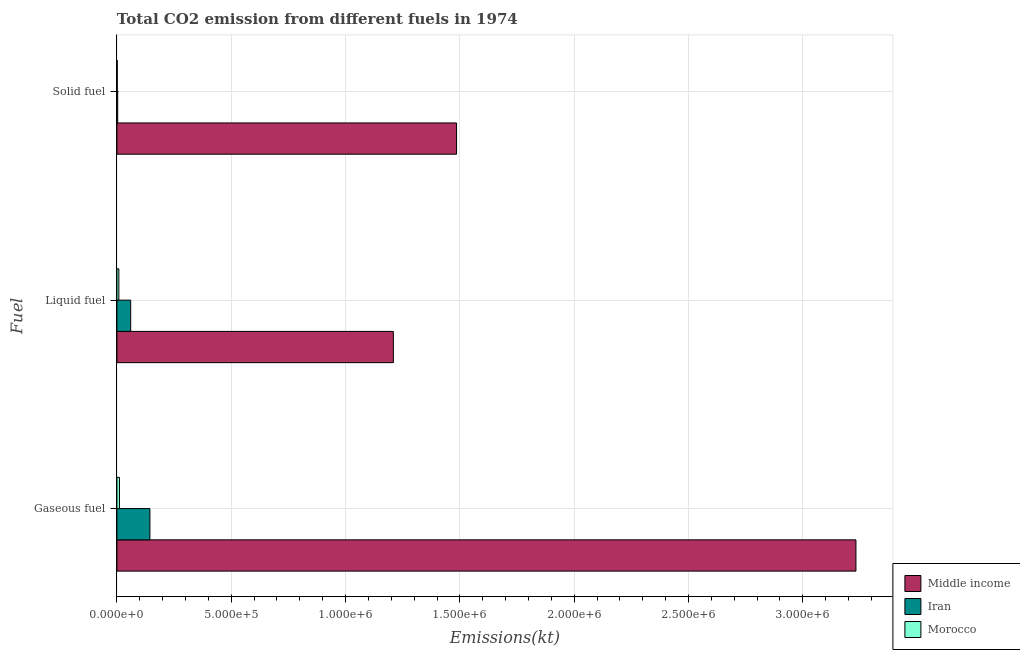How many groups of bars are there?
Offer a terse response. 3. Are the number of bars per tick equal to the number of legend labels?
Ensure brevity in your answer.  Yes. How many bars are there on the 1st tick from the bottom?
Your answer should be compact. 3. What is the label of the 3rd group of bars from the top?
Give a very brief answer. Gaseous fuel. What is the amount of co2 emissions from solid fuel in Morocco?
Provide a succinct answer. 1554.81. Across all countries, what is the maximum amount of co2 emissions from gaseous fuel?
Make the answer very short. 3.23e+06. Across all countries, what is the minimum amount of co2 emissions from gaseous fuel?
Keep it short and to the point. 1.11e+04. In which country was the amount of co2 emissions from solid fuel maximum?
Give a very brief answer. Middle income. In which country was the amount of co2 emissions from solid fuel minimum?
Provide a succinct answer. Morocco. What is the total amount of co2 emissions from liquid fuel in the graph?
Provide a succinct answer. 1.28e+06. What is the difference between the amount of co2 emissions from gaseous fuel in Morocco and that in Middle income?
Offer a very short reply. -3.22e+06. What is the difference between the amount of co2 emissions from solid fuel in Iran and the amount of co2 emissions from liquid fuel in Middle income?
Your response must be concise. -1.21e+06. What is the average amount of co2 emissions from gaseous fuel per country?
Ensure brevity in your answer.  1.13e+06. What is the difference between the amount of co2 emissions from solid fuel and amount of co2 emissions from gaseous fuel in Morocco?
Offer a terse response. -9581.87. In how many countries, is the amount of co2 emissions from gaseous fuel greater than 1600000 kt?
Offer a very short reply. 1. What is the ratio of the amount of co2 emissions from solid fuel in Iran to that in Middle income?
Provide a short and direct response. 0. What is the difference between the highest and the second highest amount of co2 emissions from solid fuel?
Ensure brevity in your answer.  1.48e+06. What is the difference between the highest and the lowest amount of co2 emissions from liquid fuel?
Your answer should be very brief. 1.20e+06. What does the 2nd bar from the bottom in Gaseous fuel represents?
Ensure brevity in your answer.  Iran. Is it the case that in every country, the sum of the amount of co2 emissions from gaseous fuel and amount of co2 emissions from liquid fuel is greater than the amount of co2 emissions from solid fuel?
Your answer should be very brief. Yes. Are all the bars in the graph horizontal?
Ensure brevity in your answer.  Yes. How many countries are there in the graph?
Give a very brief answer. 3. Are the values on the major ticks of X-axis written in scientific E-notation?
Make the answer very short. Yes. What is the title of the graph?
Your answer should be compact. Total CO2 emission from different fuels in 1974. Does "Madagascar" appear as one of the legend labels in the graph?
Ensure brevity in your answer.  No. What is the label or title of the X-axis?
Keep it short and to the point. Emissions(kt). What is the label or title of the Y-axis?
Your answer should be compact. Fuel. What is the Emissions(kt) of Middle income in Gaseous fuel?
Keep it short and to the point. 3.23e+06. What is the Emissions(kt) in Iran in Gaseous fuel?
Offer a very short reply. 1.44e+05. What is the Emissions(kt) in Morocco in Gaseous fuel?
Ensure brevity in your answer.  1.11e+04. What is the Emissions(kt) of Middle income in Liquid fuel?
Make the answer very short. 1.21e+06. What is the Emissions(kt) of Iran in Liquid fuel?
Ensure brevity in your answer.  6.02e+04. What is the Emissions(kt) in Morocco in Liquid fuel?
Your answer should be compact. 8507.44. What is the Emissions(kt) in Middle income in Solid fuel?
Keep it short and to the point. 1.49e+06. What is the Emissions(kt) of Iran in Solid fuel?
Ensure brevity in your answer.  3384.64. What is the Emissions(kt) in Morocco in Solid fuel?
Provide a short and direct response. 1554.81. Across all Fuel, what is the maximum Emissions(kt) in Middle income?
Offer a terse response. 3.23e+06. Across all Fuel, what is the maximum Emissions(kt) in Iran?
Provide a short and direct response. 1.44e+05. Across all Fuel, what is the maximum Emissions(kt) in Morocco?
Make the answer very short. 1.11e+04. Across all Fuel, what is the minimum Emissions(kt) in Middle income?
Your response must be concise. 1.21e+06. Across all Fuel, what is the minimum Emissions(kt) in Iran?
Provide a short and direct response. 3384.64. Across all Fuel, what is the minimum Emissions(kt) of Morocco?
Your answer should be very brief. 1554.81. What is the total Emissions(kt) in Middle income in the graph?
Offer a very short reply. 5.93e+06. What is the total Emissions(kt) in Iran in the graph?
Your response must be concise. 2.08e+05. What is the total Emissions(kt) in Morocco in the graph?
Make the answer very short. 2.12e+04. What is the difference between the Emissions(kt) in Middle income in Gaseous fuel and that in Liquid fuel?
Ensure brevity in your answer.  2.02e+06. What is the difference between the Emissions(kt) in Iran in Gaseous fuel and that in Liquid fuel?
Your answer should be compact. 8.41e+04. What is the difference between the Emissions(kt) in Morocco in Gaseous fuel and that in Liquid fuel?
Provide a succinct answer. 2629.24. What is the difference between the Emissions(kt) in Middle income in Gaseous fuel and that in Solid fuel?
Give a very brief answer. 1.75e+06. What is the difference between the Emissions(kt) of Iran in Gaseous fuel and that in Solid fuel?
Make the answer very short. 1.41e+05. What is the difference between the Emissions(kt) in Morocco in Gaseous fuel and that in Solid fuel?
Keep it short and to the point. 9581.87. What is the difference between the Emissions(kt) of Middle income in Liquid fuel and that in Solid fuel?
Your response must be concise. -2.76e+05. What is the difference between the Emissions(kt) of Iran in Liquid fuel and that in Solid fuel?
Keep it short and to the point. 5.68e+04. What is the difference between the Emissions(kt) of Morocco in Liquid fuel and that in Solid fuel?
Provide a short and direct response. 6952.63. What is the difference between the Emissions(kt) in Middle income in Gaseous fuel and the Emissions(kt) in Iran in Liquid fuel?
Provide a succinct answer. 3.17e+06. What is the difference between the Emissions(kt) of Middle income in Gaseous fuel and the Emissions(kt) of Morocco in Liquid fuel?
Offer a very short reply. 3.22e+06. What is the difference between the Emissions(kt) of Iran in Gaseous fuel and the Emissions(kt) of Morocco in Liquid fuel?
Offer a terse response. 1.36e+05. What is the difference between the Emissions(kt) of Middle income in Gaseous fuel and the Emissions(kt) of Iran in Solid fuel?
Your response must be concise. 3.23e+06. What is the difference between the Emissions(kt) in Middle income in Gaseous fuel and the Emissions(kt) in Morocco in Solid fuel?
Give a very brief answer. 3.23e+06. What is the difference between the Emissions(kt) of Iran in Gaseous fuel and the Emissions(kt) of Morocco in Solid fuel?
Keep it short and to the point. 1.43e+05. What is the difference between the Emissions(kt) in Middle income in Liquid fuel and the Emissions(kt) in Iran in Solid fuel?
Provide a short and direct response. 1.21e+06. What is the difference between the Emissions(kt) in Middle income in Liquid fuel and the Emissions(kt) in Morocco in Solid fuel?
Provide a succinct answer. 1.21e+06. What is the difference between the Emissions(kt) of Iran in Liquid fuel and the Emissions(kt) of Morocco in Solid fuel?
Offer a very short reply. 5.86e+04. What is the average Emissions(kt) in Middle income per Fuel?
Give a very brief answer. 1.98e+06. What is the average Emissions(kt) in Iran per Fuel?
Offer a very short reply. 6.93e+04. What is the average Emissions(kt) of Morocco per Fuel?
Keep it short and to the point. 7066.31. What is the difference between the Emissions(kt) of Middle income and Emissions(kt) of Iran in Gaseous fuel?
Ensure brevity in your answer.  3.09e+06. What is the difference between the Emissions(kt) of Middle income and Emissions(kt) of Morocco in Gaseous fuel?
Offer a terse response. 3.22e+06. What is the difference between the Emissions(kt) of Iran and Emissions(kt) of Morocco in Gaseous fuel?
Your answer should be very brief. 1.33e+05. What is the difference between the Emissions(kt) in Middle income and Emissions(kt) in Iran in Liquid fuel?
Provide a succinct answer. 1.15e+06. What is the difference between the Emissions(kt) in Middle income and Emissions(kt) in Morocco in Liquid fuel?
Your answer should be very brief. 1.20e+06. What is the difference between the Emissions(kt) of Iran and Emissions(kt) of Morocco in Liquid fuel?
Provide a short and direct response. 5.17e+04. What is the difference between the Emissions(kt) in Middle income and Emissions(kt) in Iran in Solid fuel?
Make the answer very short. 1.48e+06. What is the difference between the Emissions(kt) of Middle income and Emissions(kt) of Morocco in Solid fuel?
Make the answer very short. 1.48e+06. What is the difference between the Emissions(kt) in Iran and Emissions(kt) in Morocco in Solid fuel?
Your response must be concise. 1829.83. What is the ratio of the Emissions(kt) in Middle income in Gaseous fuel to that in Liquid fuel?
Provide a succinct answer. 2.67. What is the ratio of the Emissions(kt) of Iran in Gaseous fuel to that in Liquid fuel?
Give a very brief answer. 2.4. What is the ratio of the Emissions(kt) of Morocco in Gaseous fuel to that in Liquid fuel?
Offer a terse response. 1.31. What is the ratio of the Emissions(kt) in Middle income in Gaseous fuel to that in Solid fuel?
Make the answer very short. 2.18. What is the ratio of the Emissions(kt) of Iran in Gaseous fuel to that in Solid fuel?
Offer a very short reply. 42.62. What is the ratio of the Emissions(kt) of Morocco in Gaseous fuel to that in Solid fuel?
Your response must be concise. 7.16. What is the ratio of the Emissions(kt) in Middle income in Liquid fuel to that in Solid fuel?
Offer a terse response. 0.81. What is the ratio of the Emissions(kt) in Iran in Liquid fuel to that in Solid fuel?
Your response must be concise. 17.79. What is the ratio of the Emissions(kt) of Morocco in Liquid fuel to that in Solid fuel?
Your response must be concise. 5.47. What is the difference between the highest and the second highest Emissions(kt) in Middle income?
Make the answer very short. 1.75e+06. What is the difference between the highest and the second highest Emissions(kt) of Iran?
Provide a succinct answer. 8.41e+04. What is the difference between the highest and the second highest Emissions(kt) of Morocco?
Your answer should be compact. 2629.24. What is the difference between the highest and the lowest Emissions(kt) in Middle income?
Offer a very short reply. 2.02e+06. What is the difference between the highest and the lowest Emissions(kt) of Iran?
Your response must be concise. 1.41e+05. What is the difference between the highest and the lowest Emissions(kt) of Morocco?
Give a very brief answer. 9581.87. 